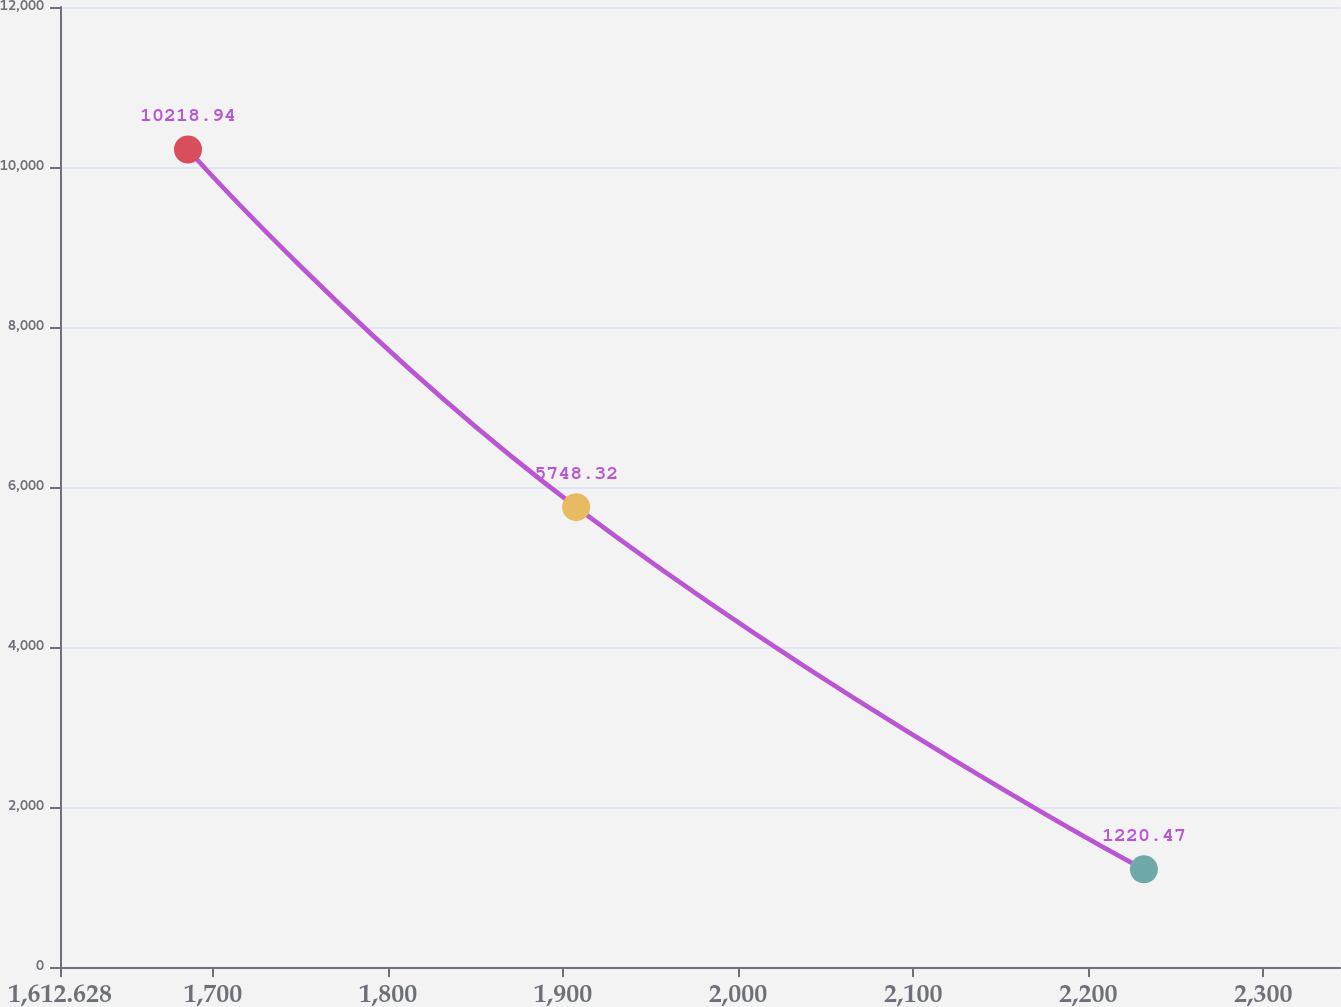Convert chart. <chart><loc_0><loc_0><loc_500><loc_500><line_chart><ecel><fcel>Unnamed: 1<nl><fcel>1685.75<fcel>10218.9<nl><fcel>1907.49<fcel>5748.32<nl><fcel>2231.83<fcel>1220.47<nl><fcel>2347.2<fcel>2220.3<nl><fcel>2416.97<fcel>220.64<nl></chart> 